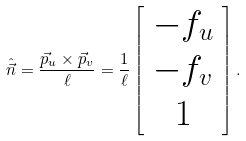Convert formula to latex. <formula><loc_0><loc_0><loc_500><loc_500>\hat { \vec { n } } = \frac { \vec { p } _ { u } \times \vec { p } _ { v } } { \ell } = \frac { 1 } { \ell } \left [ \begin{array} { c } - f _ { u } \\ - f _ { v } \\ 1 \end{array} \right ] .</formula> 